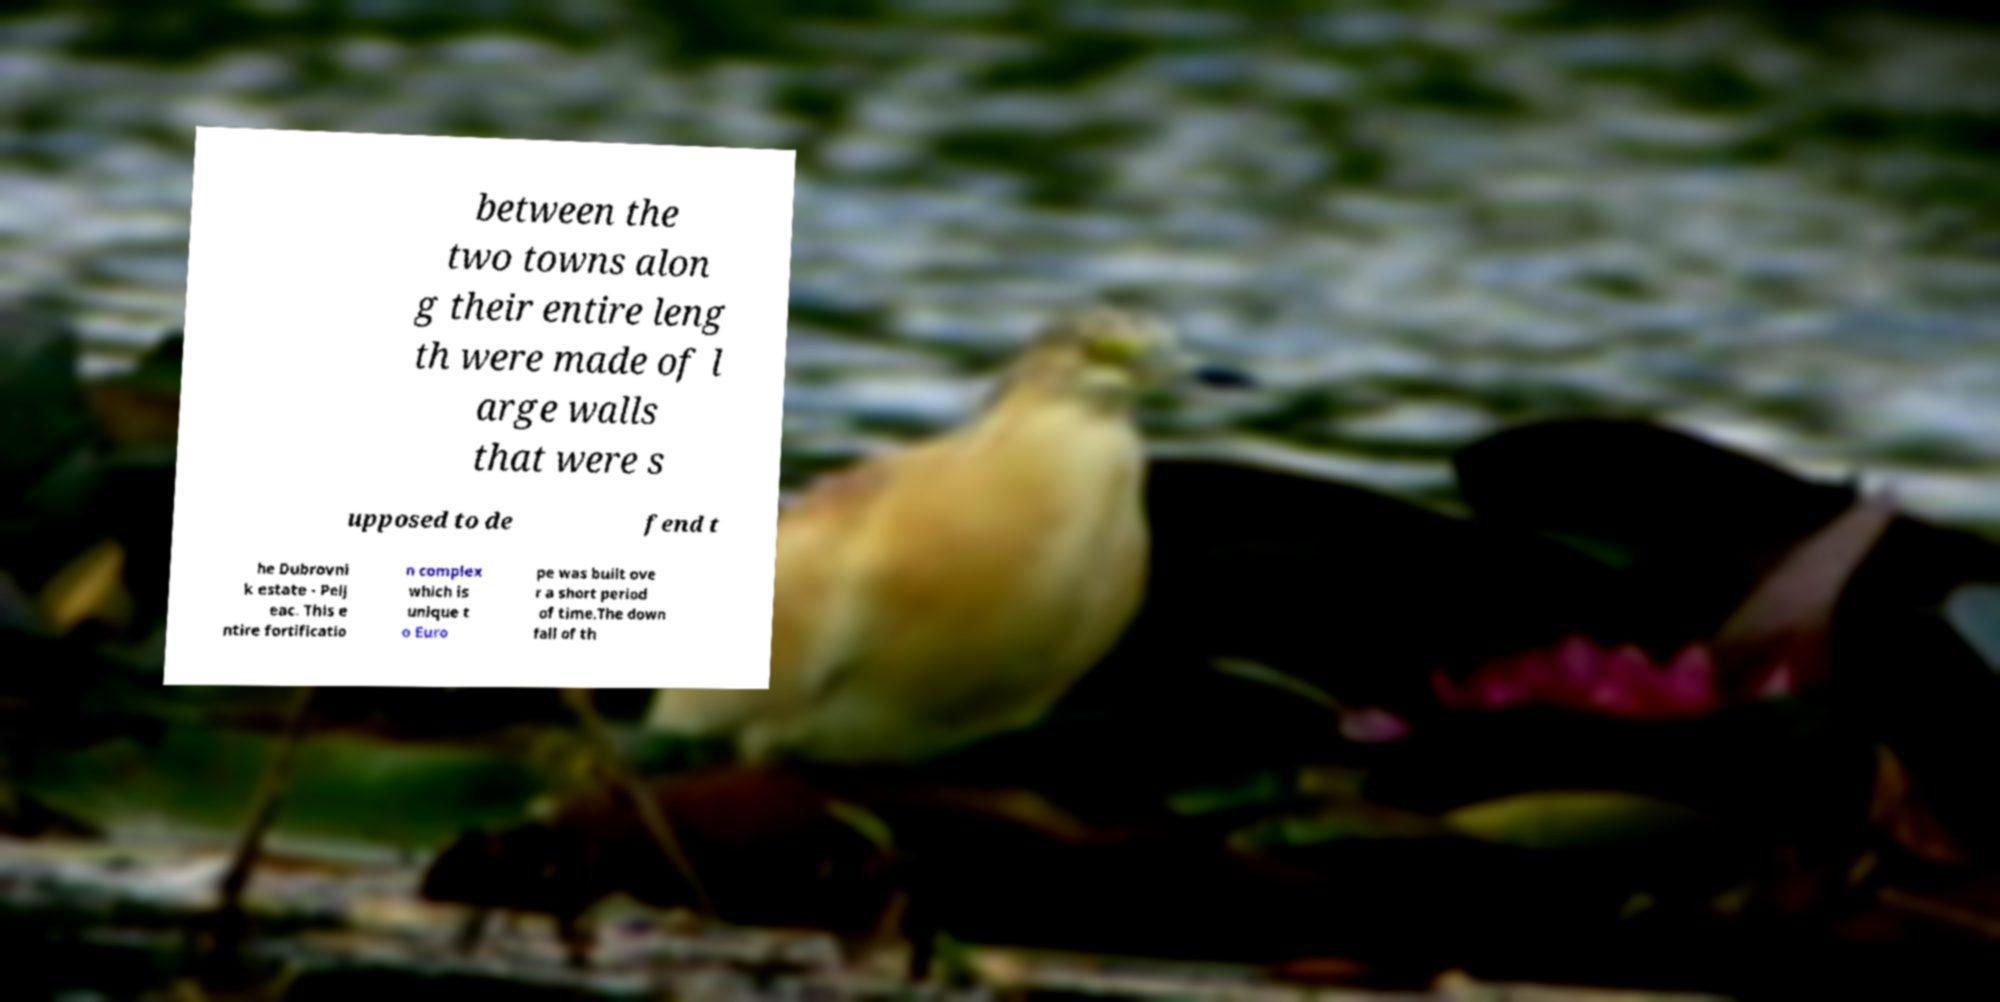Can you accurately transcribe the text from the provided image for me? between the two towns alon g their entire leng th were made of l arge walls that were s upposed to de fend t he Dubrovni k estate - Pelj eac. This e ntire fortificatio n complex which is unique t o Euro pe was built ove r a short period of time.The down fall of th 